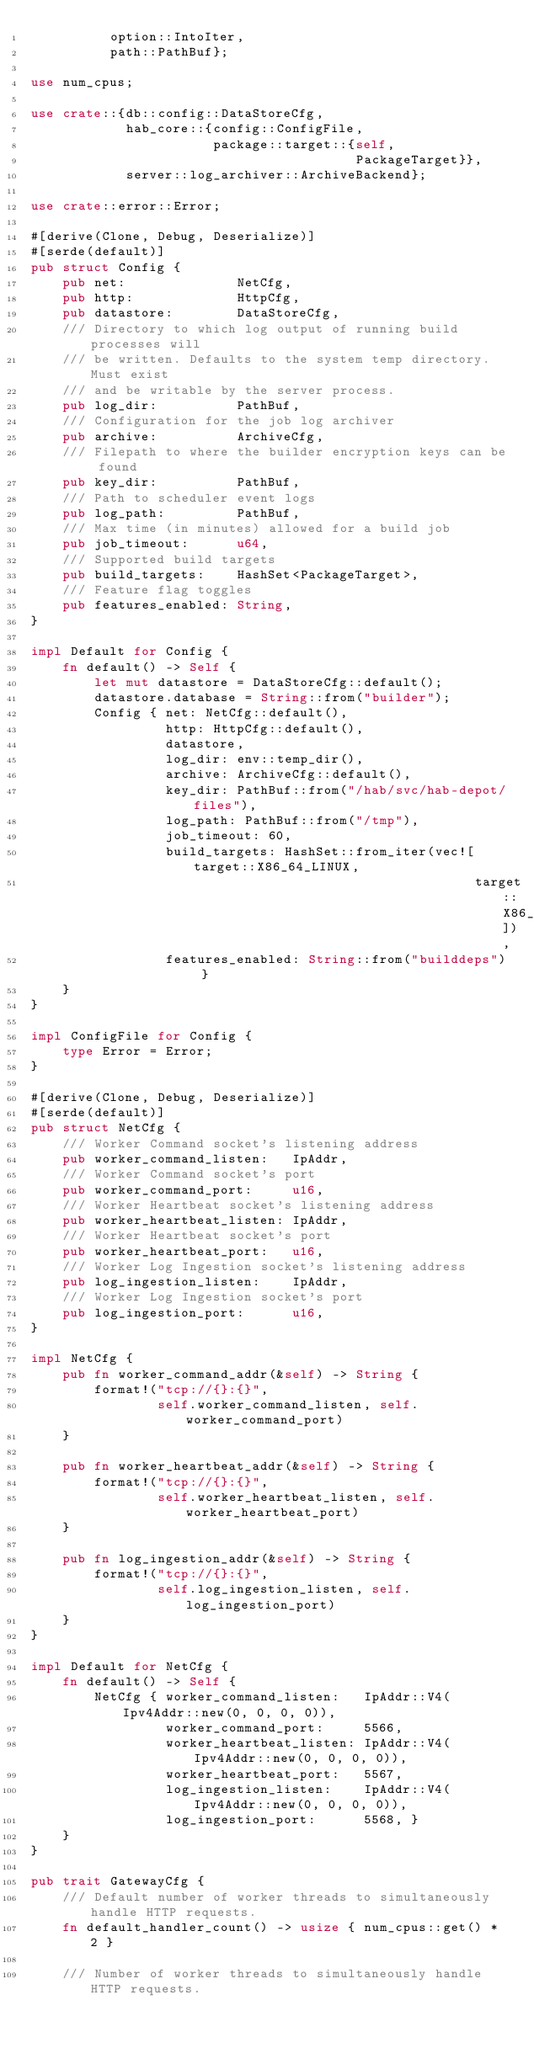<code> <loc_0><loc_0><loc_500><loc_500><_Rust_>          option::IntoIter,
          path::PathBuf};

use num_cpus;

use crate::{db::config::DataStoreCfg,
            hab_core::{config::ConfigFile,
                       package::target::{self,
                                         PackageTarget}},
            server::log_archiver::ArchiveBackend};

use crate::error::Error;

#[derive(Clone, Debug, Deserialize)]
#[serde(default)]
pub struct Config {
    pub net:              NetCfg,
    pub http:             HttpCfg,
    pub datastore:        DataStoreCfg,
    /// Directory to which log output of running build processes will
    /// be written. Defaults to the system temp directory. Must exist
    /// and be writable by the server process.
    pub log_dir:          PathBuf,
    /// Configuration for the job log archiver
    pub archive:          ArchiveCfg,
    /// Filepath to where the builder encryption keys can be found
    pub key_dir:          PathBuf,
    /// Path to scheduler event logs
    pub log_path:         PathBuf,
    /// Max time (in minutes) allowed for a build job
    pub job_timeout:      u64,
    /// Supported build targets
    pub build_targets:    HashSet<PackageTarget>,
    /// Feature flag toggles
    pub features_enabled: String,
}

impl Default for Config {
    fn default() -> Self {
        let mut datastore = DataStoreCfg::default();
        datastore.database = String::from("builder");
        Config { net: NetCfg::default(),
                 http: HttpCfg::default(),
                 datastore,
                 log_dir: env::temp_dir(),
                 archive: ArchiveCfg::default(),
                 key_dir: PathBuf::from("/hab/svc/hab-depot/files"),
                 log_path: PathBuf::from("/tmp"),
                 job_timeout: 60,
                 build_targets: HashSet::from_iter(vec![target::X86_64_LINUX,
                                                        target::X86_64_WINDOWS]),
                 features_enabled: String::from("builddeps") }
    }
}

impl ConfigFile for Config {
    type Error = Error;
}

#[derive(Clone, Debug, Deserialize)]
#[serde(default)]
pub struct NetCfg {
    /// Worker Command socket's listening address
    pub worker_command_listen:   IpAddr,
    /// Worker Command socket's port
    pub worker_command_port:     u16,
    /// Worker Heartbeat socket's listening address
    pub worker_heartbeat_listen: IpAddr,
    /// Worker Heartbeat socket's port
    pub worker_heartbeat_port:   u16,
    /// Worker Log Ingestion socket's listening address
    pub log_ingestion_listen:    IpAddr,
    /// Worker Log Ingestion socket's port
    pub log_ingestion_port:      u16,
}

impl NetCfg {
    pub fn worker_command_addr(&self) -> String {
        format!("tcp://{}:{}",
                self.worker_command_listen, self.worker_command_port)
    }

    pub fn worker_heartbeat_addr(&self) -> String {
        format!("tcp://{}:{}",
                self.worker_heartbeat_listen, self.worker_heartbeat_port)
    }

    pub fn log_ingestion_addr(&self) -> String {
        format!("tcp://{}:{}",
                self.log_ingestion_listen, self.log_ingestion_port)
    }
}

impl Default for NetCfg {
    fn default() -> Self {
        NetCfg { worker_command_listen:   IpAddr::V4(Ipv4Addr::new(0, 0, 0, 0)),
                 worker_command_port:     5566,
                 worker_heartbeat_listen: IpAddr::V4(Ipv4Addr::new(0, 0, 0, 0)),
                 worker_heartbeat_port:   5567,
                 log_ingestion_listen:    IpAddr::V4(Ipv4Addr::new(0, 0, 0, 0)),
                 log_ingestion_port:      5568, }
    }
}

pub trait GatewayCfg {
    /// Default number of worker threads to simultaneously handle HTTP requests.
    fn default_handler_count() -> usize { num_cpus::get() * 2 }

    /// Number of worker threads to simultaneously handle HTTP requests.</code> 